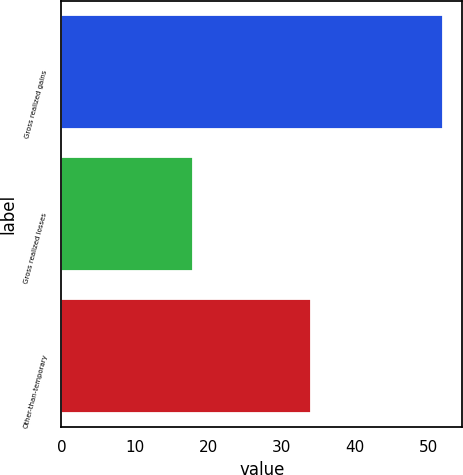<chart> <loc_0><loc_0><loc_500><loc_500><bar_chart><fcel>Gross realized gains<fcel>Gross realized losses<fcel>Other-than-temporary<nl><fcel>52<fcel>18<fcel>34<nl></chart> 